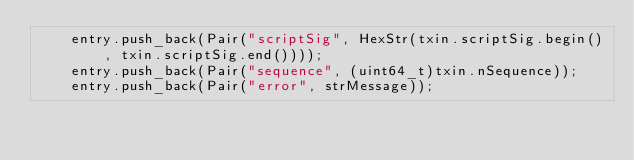Convert code to text. <code><loc_0><loc_0><loc_500><loc_500><_C++_>    entry.push_back(Pair("scriptSig", HexStr(txin.scriptSig.begin(), txin.scriptSig.end())));
    entry.push_back(Pair("sequence", (uint64_t)txin.nSequence));
    entry.push_back(Pair("error", strMessage));</code> 